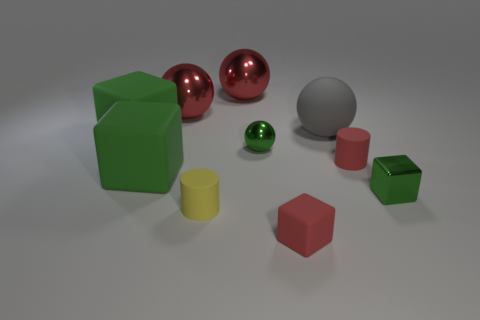Is there a tiny gray cube that has the same material as the small red block?
Make the answer very short. No. There is a yellow rubber object; what shape is it?
Provide a succinct answer. Cylinder. What number of objects are there?
Your answer should be compact. 10. What is the color of the tiny metal object that is to the left of the small metallic thing right of the tiny shiny ball?
Keep it short and to the point. Green. There is a shiny block that is the same size as the red rubber cylinder; what is its color?
Your answer should be very brief. Green. Are there any large shiny balls of the same color as the small matte cube?
Your answer should be very brief. Yes. Are there any large green matte blocks?
Your answer should be compact. Yes. What shape is the small green thing on the right side of the large gray ball?
Provide a succinct answer. Cube. How many tiny objects are behind the red matte block and in front of the red matte cylinder?
Make the answer very short. 2. What number of other objects are the same size as the red rubber cylinder?
Make the answer very short. 4. 